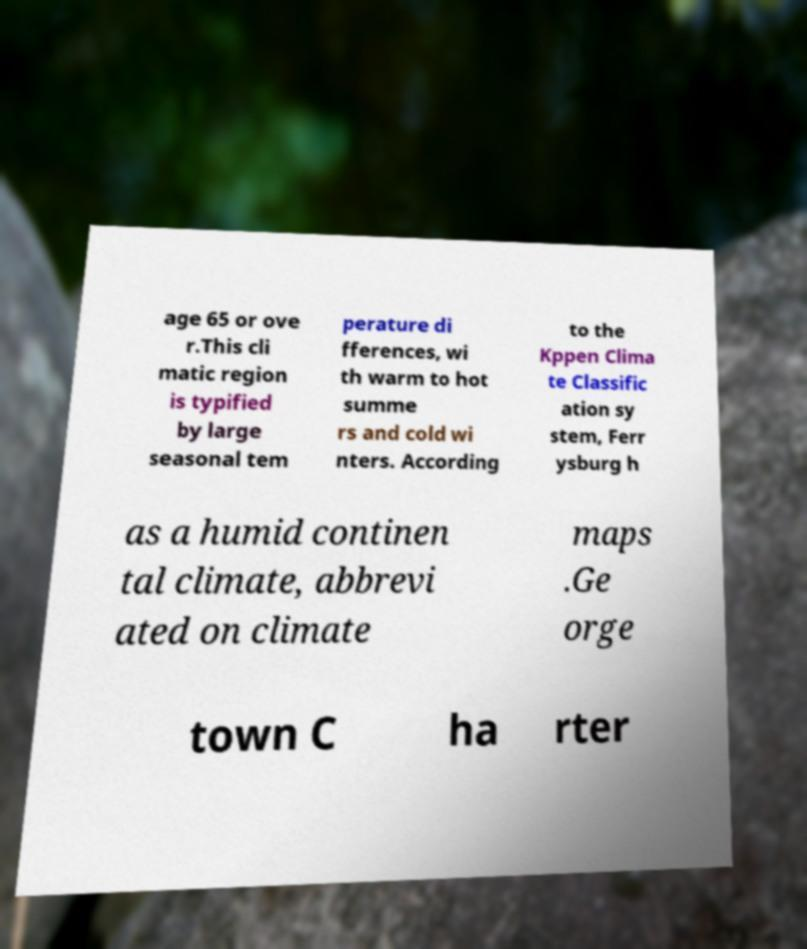Please read and relay the text visible in this image. What does it say? age 65 or ove r.This cli matic region is typified by large seasonal tem perature di fferences, wi th warm to hot summe rs and cold wi nters. According to the Kppen Clima te Classific ation sy stem, Ferr ysburg h as a humid continen tal climate, abbrevi ated on climate maps .Ge orge town C ha rter 